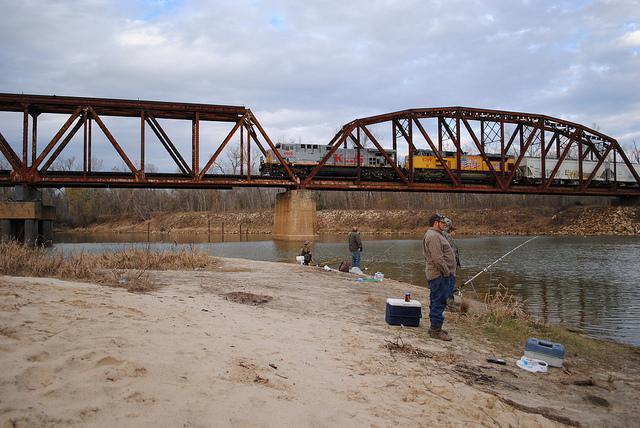What do the men hope to bring home?
From the following set of four choices, select the accurate answer to respond to the question.
Options: Car, dog, fish, women. Fish. 